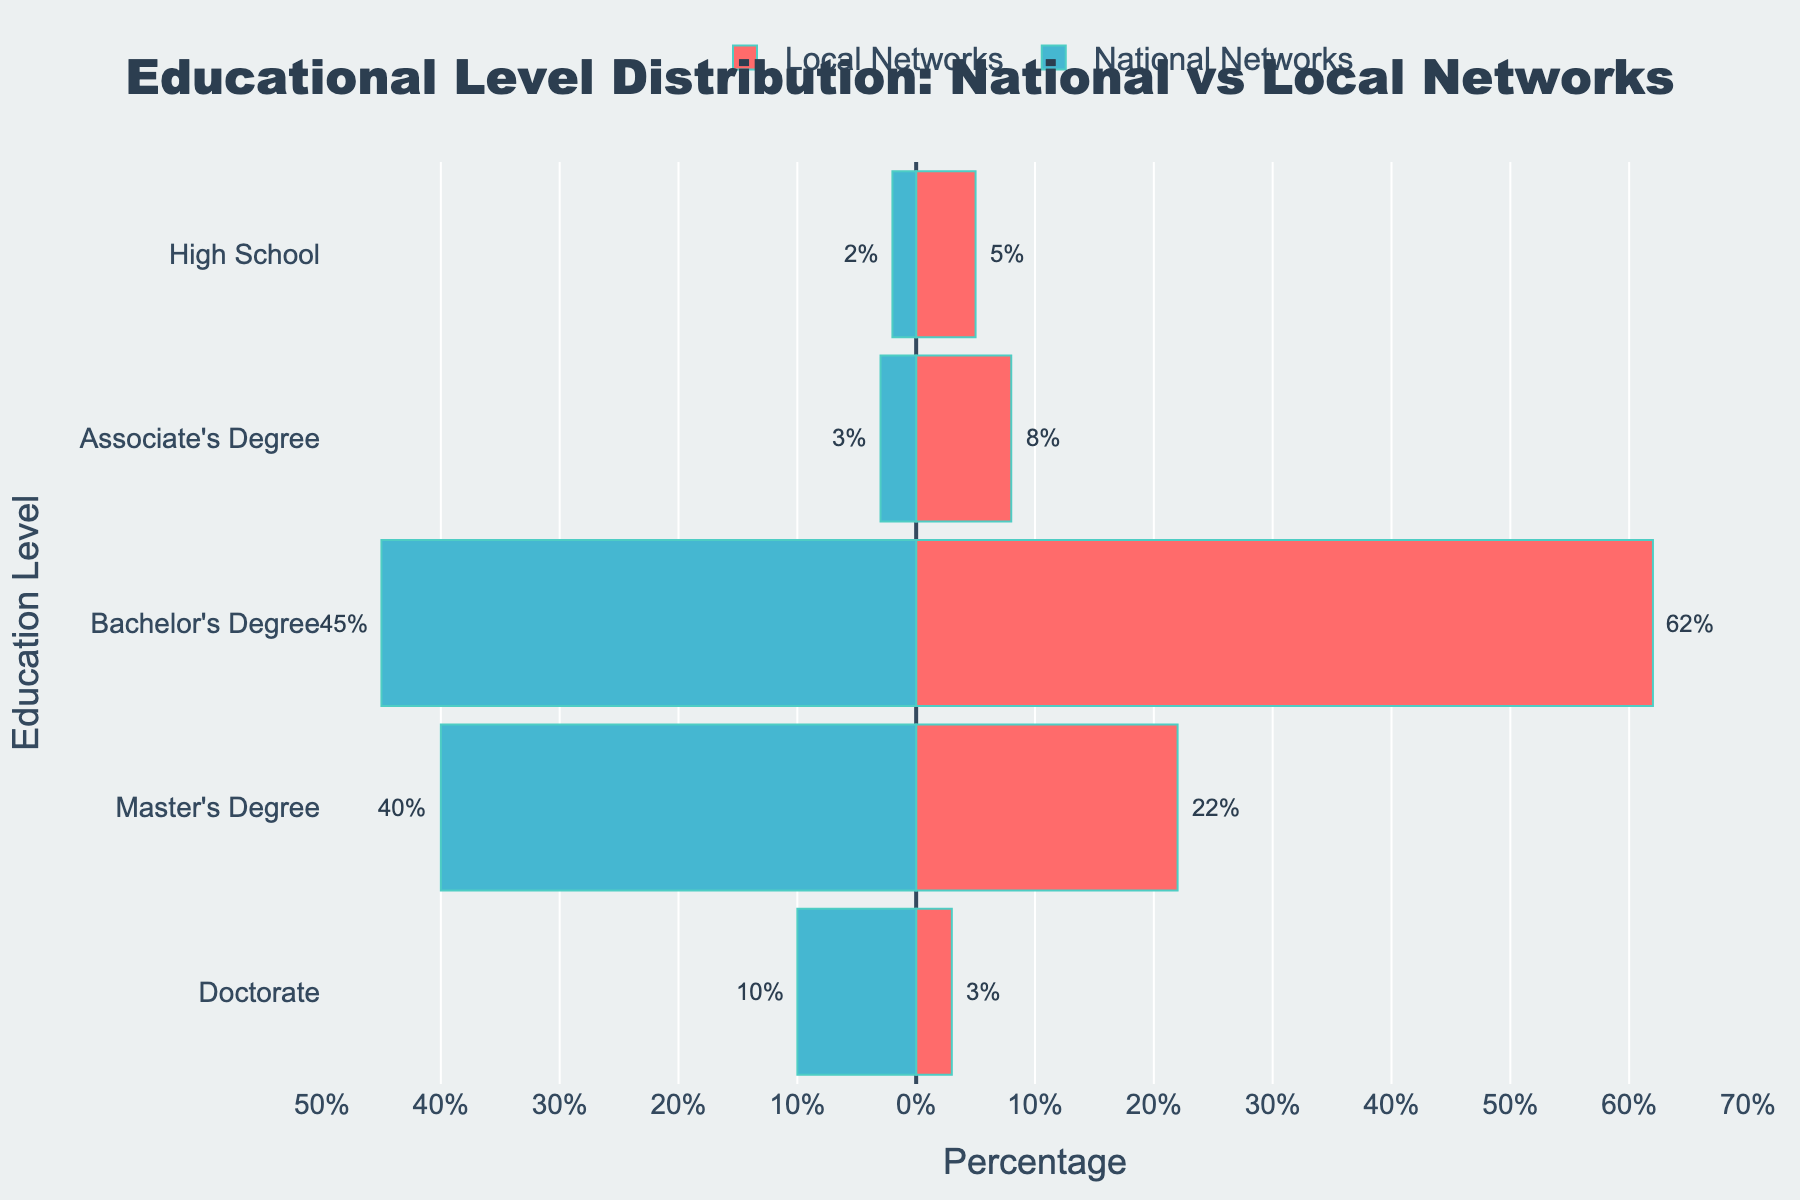What percentage of Bachelor's Degree holders work in Local Networks? The percentage of Bachelor's Degree holders in Local Networks is indicated by the pink bar in the Bachelor's Degree row, which is labeled with a value of 62%.
Answer: 62% Which education level has the smallest percentage of representation in National Networks? Find the smallest negative value among the percentages for National Networks. The smallest percentage is for High School, with -2%.
Answer: High School What's the total percentage of Master's Degree holders in both National and Local Networks combined? Add the positive value of Master's Degree holders in Local Networks (22%) to the absolute value of Master's Degree holders in National Networks (40%); 22% + 40% = 62%.
Answer: 62% How does the distribution of Doctorate holders compare between National and Local Networks? The percentage of Doctorate holders is represented by -10% for National Networks and 3% for Local Networks. The National Networks have a higher representation of Doctorate holders compared to Local Networks.
Answer: National Networks have more Which education level shows the most significant difference in representation between National and Local Networks? Calculate the absolute difference for each education level between National and Local Networks. Bachelor's Degree shows the largest difference: 62% (Local) - 45% (National) = 17%.
Answer: Bachelor's Degree What is the average percentage of reporters with an Associate's Degree in both types of networks? Sum the percentages for Associate's Degree in both networks and divide by 2. Associate's Degree percentages are 8% (Local) and 3% (National). The average is (8% + 3%)/2 = 5.5%.
Answer: 5.5% Which network has a higher percentage of higher education (Master's Degree and Doctorate combined) holders? Sum the percentages for Master's Degree and Doctorate for both networks. Local: 22% (Master's) + 3% (Doctorate) = 25%. National: 40% (Master's) + 10% (Doctorate) = 50%. National Networks have a higher percentage.
Answer: National Networks 